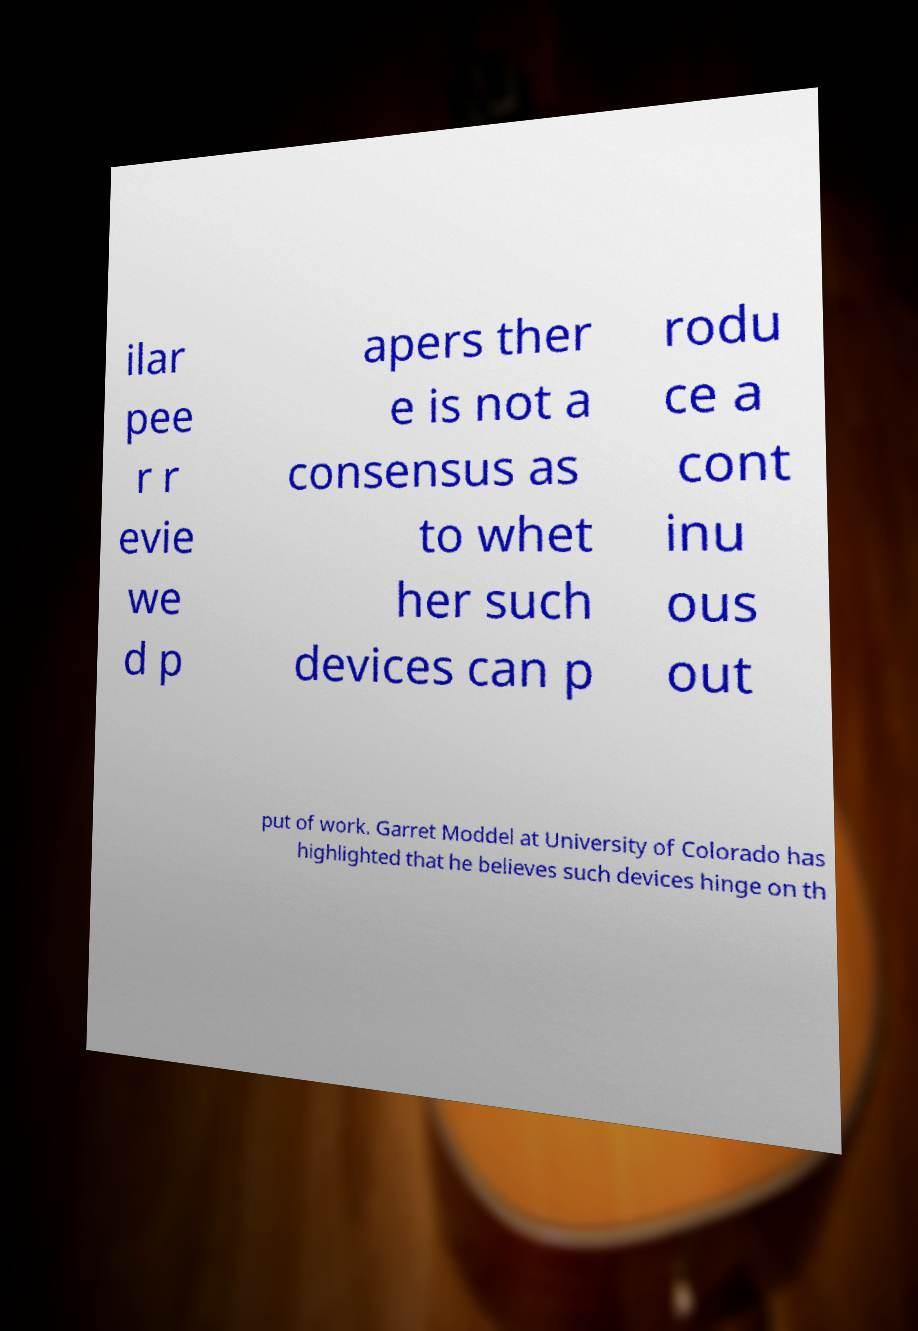Could you assist in decoding the text presented in this image and type it out clearly? ilar pee r r evie we d p apers ther e is not a consensus as to whet her such devices can p rodu ce a cont inu ous out put of work. Garret Moddel at University of Colorado has highlighted that he believes such devices hinge on th 